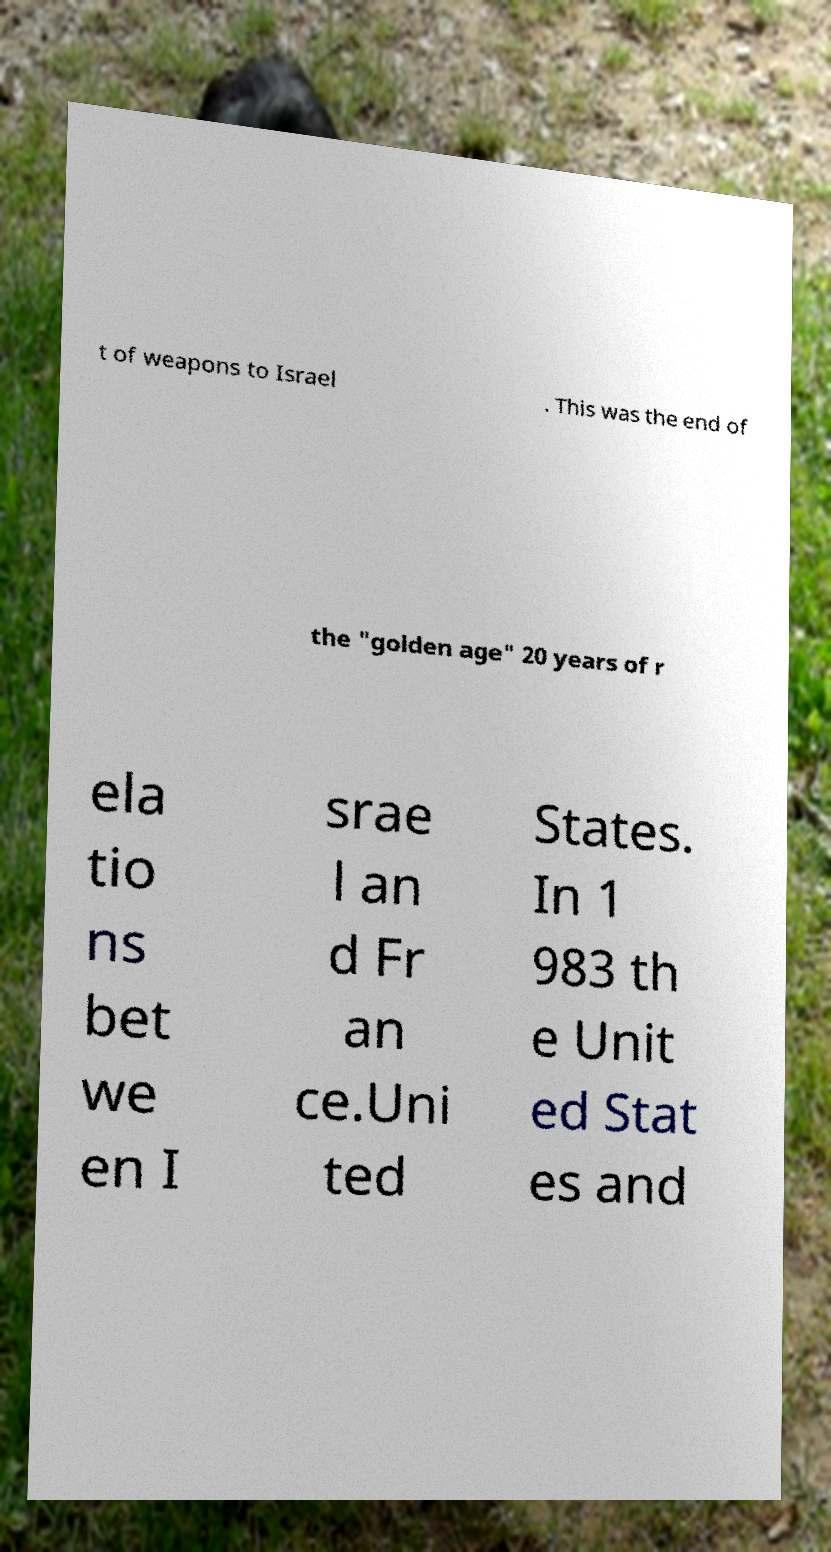What messages or text are displayed in this image? I need them in a readable, typed format. t of weapons to Israel . This was the end of the "golden age" 20 years of r ela tio ns bet we en I srae l an d Fr an ce.Uni ted States. In 1 983 th e Unit ed Stat es and 